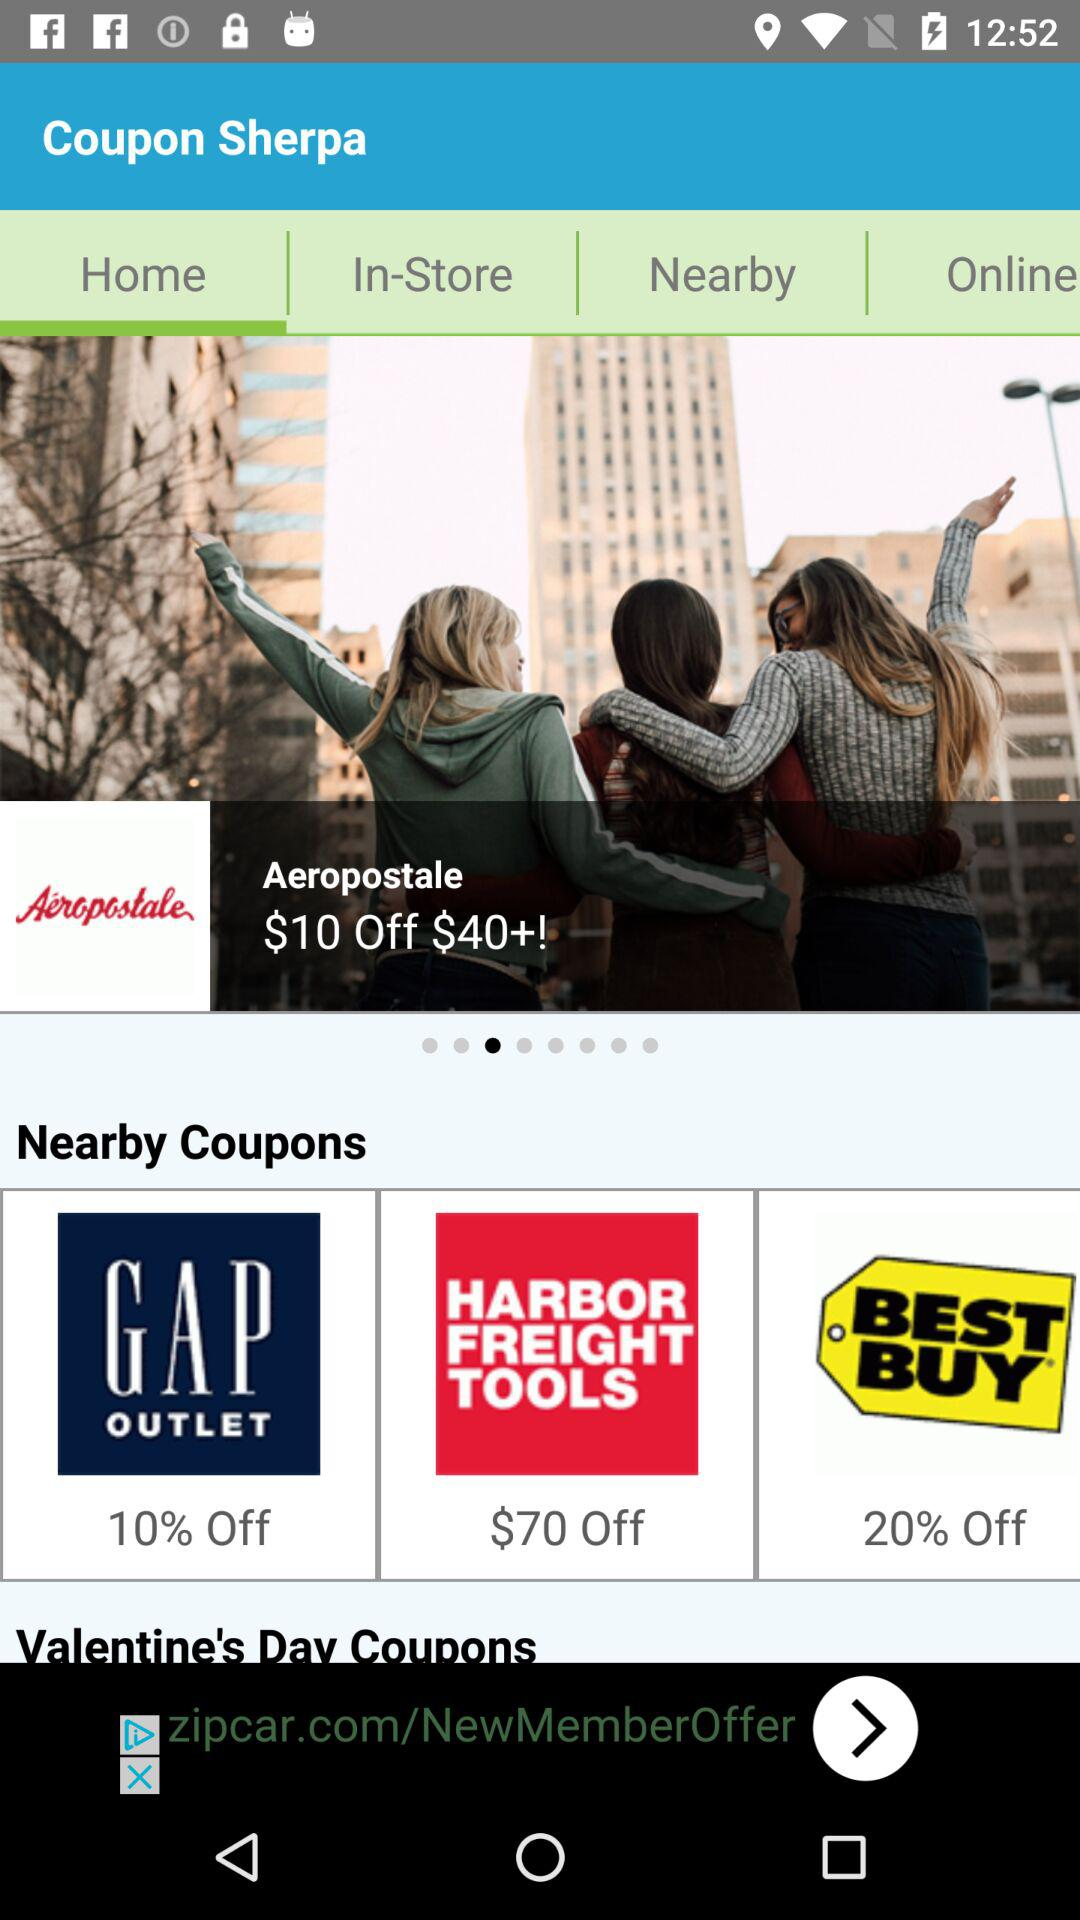Which are the available nearby coupons? The available coupons are "10% Off on GAP OUTLET", "$70 Off on HARBOR FREIGHT TOOLS" and "20% Off on BEST BUY". 